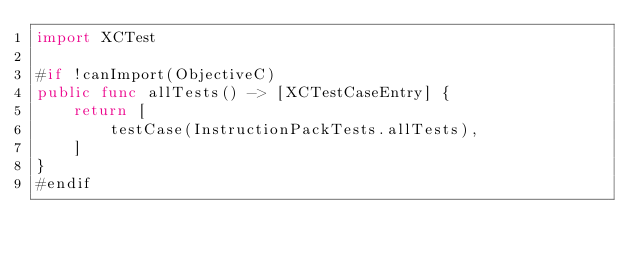Convert code to text. <code><loc_0><loc_0><loc_500><loc_500><_Swift_>import XCTest

#if !canImport(ObjectiveC)
public func allTests() -> [XCTestCaseEntry] {
    return [
        testCase(InstructionPackTests.allTests),
    ]
}
#endif
</code> 